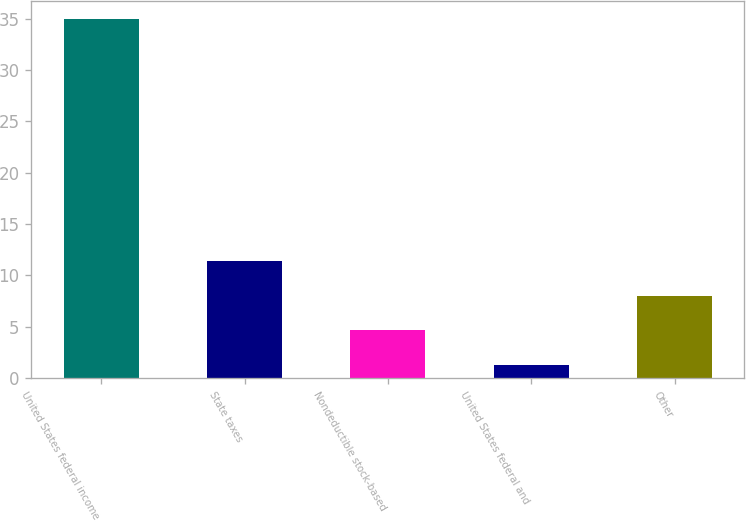Convert chart to OTSL. <chart><loc_0><loc_0><loc_500><loc_500><bar_chart><fcel>United States federal income<fcel>State taxes<fcel>Nondeductible stock-based<fcel>United States federal and<fcel>Other<nl><fcel>35<fcel>11.41<fcel>4.67<fcel>1.3<fcel>8.04<nl></chart> 